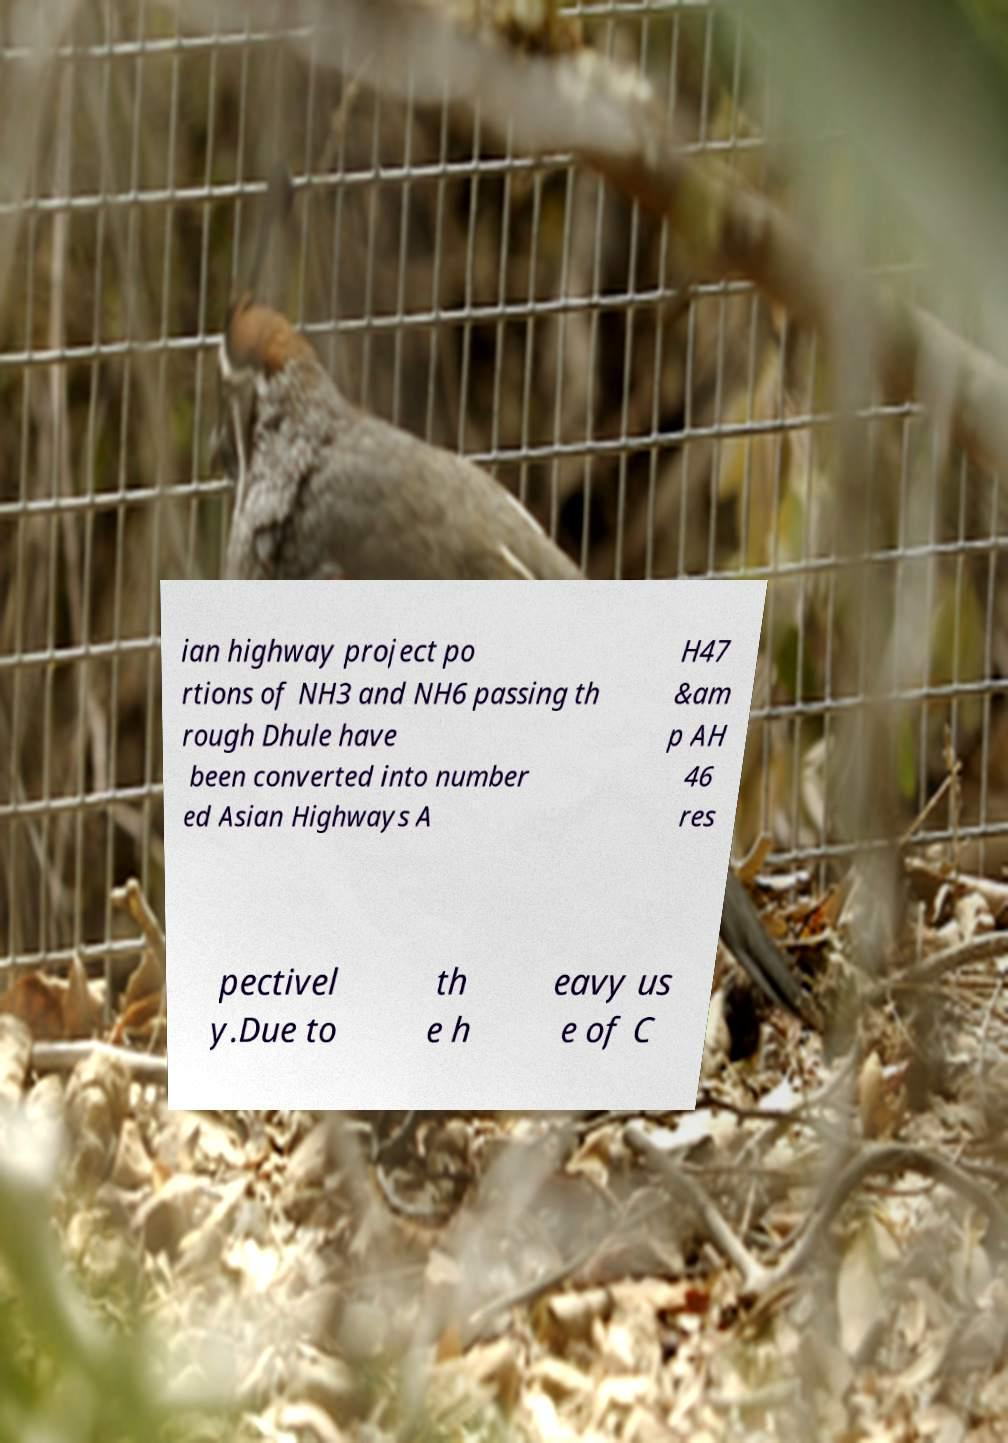Could you assist in decoding the text presented in this image and type it out clearly? ian highway project po rtions of NH3 and NH6 passing th rough Dhule have been converted into number ed Asian Highways A H47 &am p AH 46 res pectivel y.Due to th e h eavy us e of C 